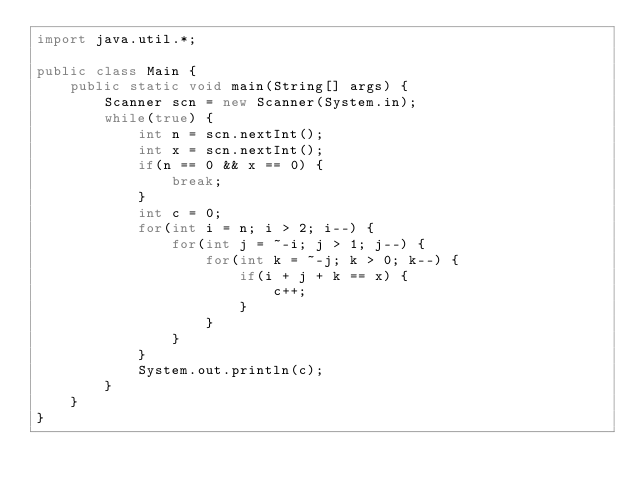Convert code to text. <code><loc_0><loc_0><loc_500><loc_500><_Java_>import java.util.*;

public class Main {
    public static void main(String[] args) {
        Scanner scn = new Scanner(System.in);
        while(true) {
            int n = scn.nextInt();
            int x = scn.nextInt();
            if(n == 0 && x == 0) {
                break;
            }
            int c = 0;
            for(int i = n; i > 2; i--) {
                for(int j = ~-i; j > 1; j--) {
                    for(int k = ~-j; k > 0; k--) {
                        if(i + j + k == x) {
                            c++;
                        }
                    }
                }
            }
            System.out.println(c);
        }
    }
}</code> 